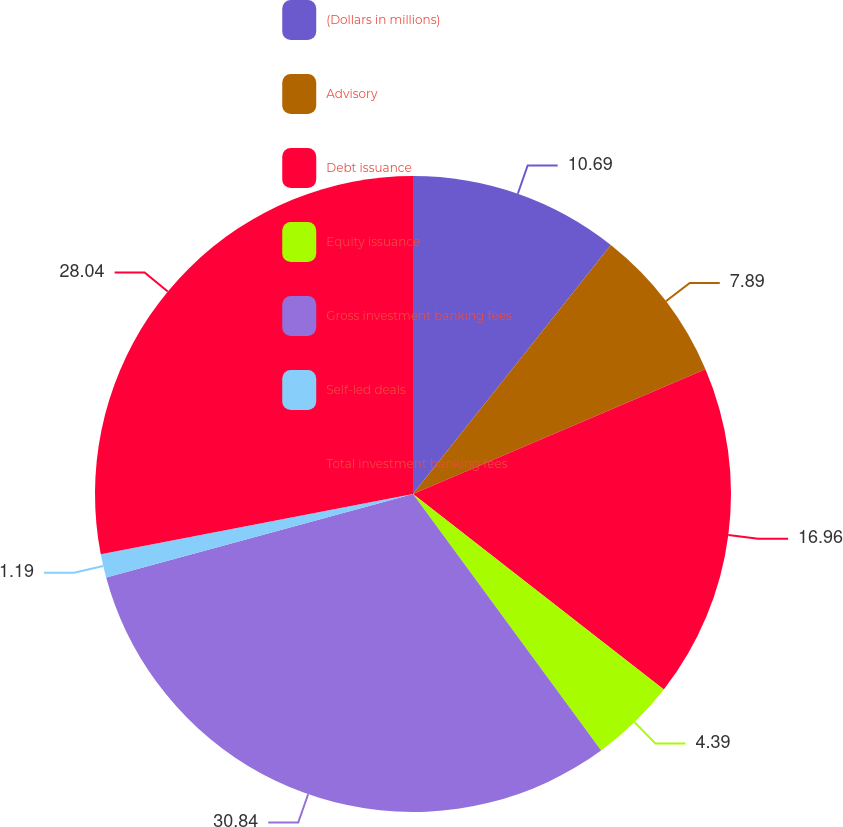<chart> <loc_0><loc_0><loc_500><loc_500><pie_chart><fcel>(Dollars in millions)<fcel>Advisory<fcel>Debt issuance<fcel>Equity issuance<fcel>Gross investment banking fees<fcel>Self-led deals<fcel>Total investment banking fees<nl><fcel>10.69%<fcel>7.89%<fcel>16.96%<fcel>4.39%<fcel>30.85%<fcel>1.19%<fcel>28.04%<nl></chart> 